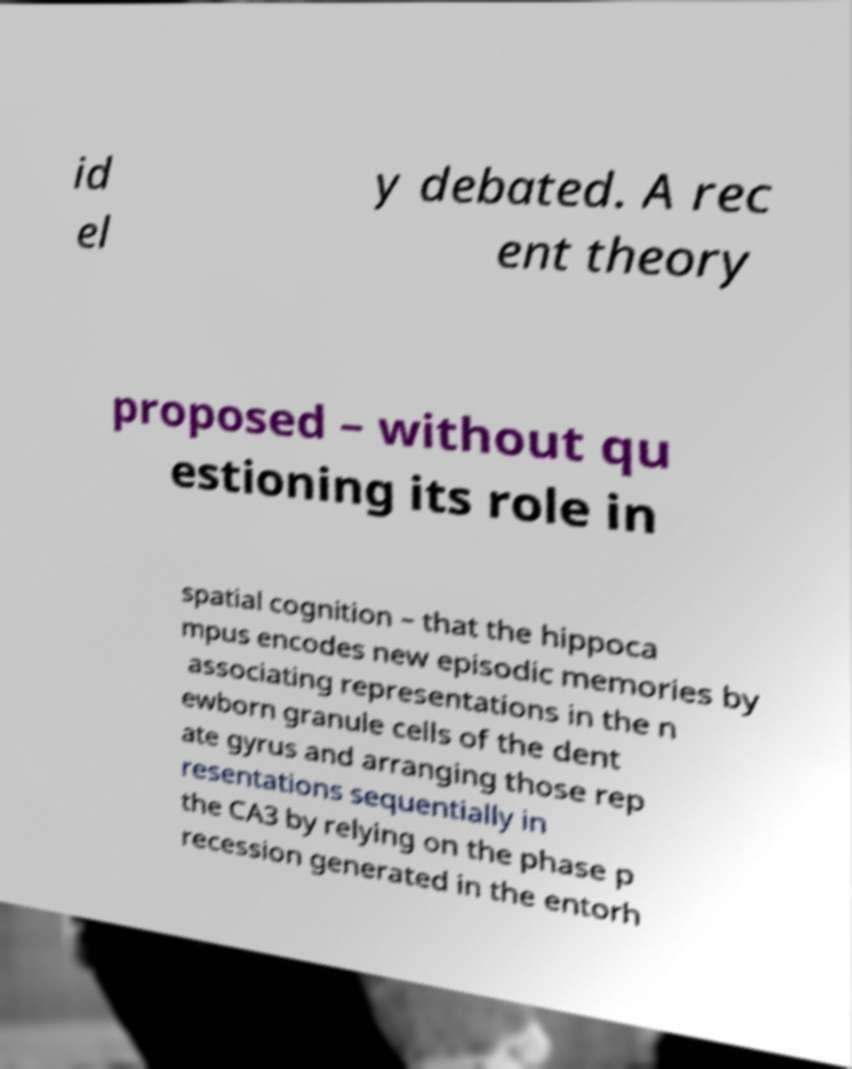What messages or text are displayed in this image? I need them in a readable, typed format. id el y debated. A rec ent theory proposed – without qu estioning its role in spatial cognition – that the hippoca mpus encodes new episodic memories by associating representations in the n ewborn granule cells of the dent ate gyrus and arranging those rep resentations sequentially in the CA3 by relying on the phase p recession generated in the entorh 